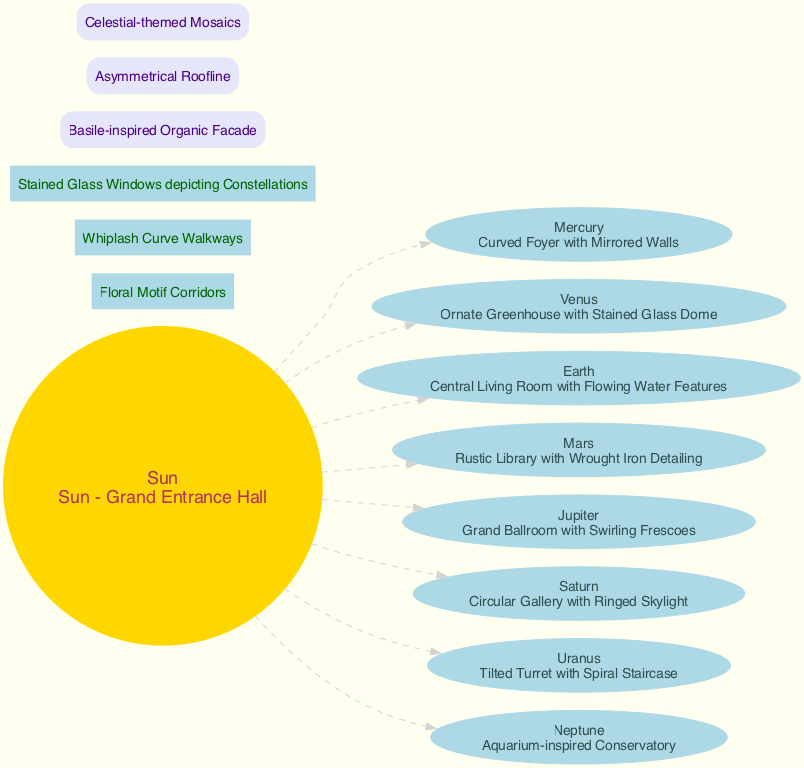What is the central element depicted in the diagram? The central element of the diagram is explicitly stated as the "Sun - Grand Entrance Hall", which is the focal point of the design.
Answer: Sun - Grand Entrance Hall Which planet is represented by the Ornate Greenhouse with Stained Glass Dome? The diagram indicates that Venus is represented by the element "Ornate Greenhouse with Stained Glass Dome." This is directly tied to the label associated with Venus in the nodes.
Answer: Venus How many connecting elements are there in the diagram? The diagram lists three connecting elements, which are "Floral Motif Corridors," "Whiplash Curve Walkways," and "Stained Glass Windows depicting Constellations." A count of these elements gives the answer.
Answer: 3 What architectural element represents Earth in the diagram? Earth is represented by the "Central Living Room with Flowing Water Features," found in the list of planets and their corresponding elements in the diagram.
Answer: Central Living Room with Flowing Water Features Which planet is associated with a Rustic Library with Wrought Iron Detailing? The diagram shows that Mars is the planet associated with the "Rustic Library with Wrought Iron Detailing." This association is directly mentioned under Mars.
Answer: Mars What type of exterior feature is described as having a "Celestial-themed Mosaics"? The exterior feature labeled "Celestial-themed Mosaics" is one of the design elements of the building, listed under the exterior features in the diagram.
Answer: Celestial-themed Mosaics Which planet connects to the Sun through a dashed line in the diagram? All planets connect to the Sun through dashed lines, including Mercury, Venus, Earth, Mars, Jupiter, Saturn, Uranus, and Neptune; this is the defining characteristic of their relationships in the diagram.
Answer: All planets What feature connects the different elements in the diagram? The features that connect the different elements are the specified connecting elements which include "Floral Motif Corridors," "Whiplash Curve Walkways," and "Stained Glass Windows depicting Constellations." This defines the transitions in the structure.
Answer: Floral Motif Corridors, Whiplash Curve Walkways, Stained Glass Windows depicting Constellations 